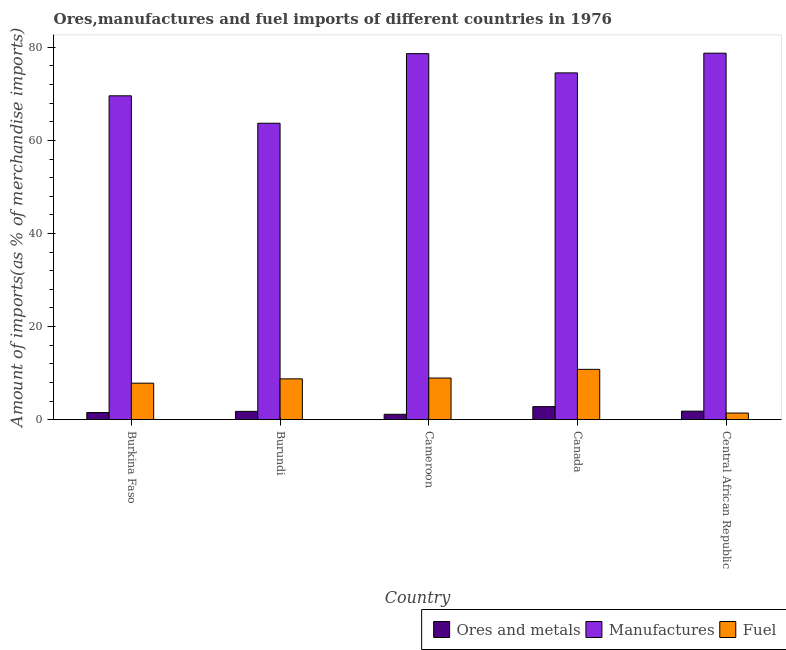Are the number of bars on each tick of the X-axis equal?
Make the answer very short. Yes. How many bars are there on the 4th tick from the left?
Your answer should be very brief. 3. How many bars are there on the 2nd tick from the right?
Make the answer very short. 3. What is the label of the 5th group of bars from the left?
Provide a short and direct response. Central African Republic. What is the percentage of manufactures imports in Cameroon?
Offer a very short reply. 78.63. Across all countries, what is the maximum percentage of manufactures imports?
Keep it short and to the point. 78.73. Across all countries, what is the minimum percentage of manufactures imports?
Make the answer very short. 63.69. In which country was the percentage of ores and metals imports maximum?
Offer a very short reply. Canada. In which country was the percentage of ores and metals imports minimum?
Give a very brief answer. Cameroon. What is the total percentage of manufactures imports in the graph?
Offer a very short reply. 365.13. What is the difference between the percentage of ores and metals imports in Canada and that in Central African Republic?
Provide a short and direct response. 0.97. What is the difference between the percentage of fuel imports in Burkina Faso and the percentage of ores and metals imports in Burundi?
Give a very brief answer. 6.06. What is the average percentage of ores and metals imports per country?
Offer a very short reply. 1.82. What is the difference between the percentage of ores and metals imports and percentage of manufactures imports in Cameroon?
Make the answer very short. -77.48. In how many countries, is the percentage of manufactures imports greater than 24 %?
Offer a very short reply. 5. What is the ratio of the percentage of fuel imports in Cameroon to that in Central African Republic?
Offer a terse response. 6.28. Is the difference between the percentage of ores and metals imports in Burkina Faso and Burundi greater than the difference between the percentage of manufactures imports in Burkina Faso and Burundi?
Give a very brief answer. No. What is the difference between the highest and the second highest percentage of fuel imports?
Your answer should be very brief. 1.87. What is the difference between the highest and the lowest percentage of fuel imports?
Your answer should be compact. 9.39. In how many countries, is the percentage of manufactures imports greater than the average percentage of manufactures imports taken over all countries?
Give a very brief answer. 3. What does the 2nd bar from the left in Burkina Faso represents?
Give a very brief answer. Manufactures. What does the 1st bar from the right in Central African Republic represents?
Your answer should be very brief. Fuel. Is it the case that in every country, the sum of the percentage of ores and metals imports and percentage of manufactures imports is greater than the percentage of fuel imports?
Give a very brief answer. Yes. How many bars are there?
Your answer should be compact. 15. Are all the bars in the graph horizontal?
Offer a very short reply. No. How many countries are there in the graph?
Provide a succinct answer. 5. Does the graph contain any zero values?
Provide a succinct answer. No. Where does the legend appear in the graph?
Offer a very short reply. Bottom right. How many legend labels are there?
Your answer should be compact. 3. How are the legend labels stacked?
Give a very brief answer. Horizontal. What is the title of the graph?
Keep it short and to the point. Ores,manufactures and fuel imports of different countries in 1976. What is the label or title of the X-axis?
Give a very brief answer. Country. What is the label or title of the Y-axis?
Offer a terse response. Amount of imports(as % of merchandise imports). What is the Amount of imports(as % of merchandise imports) in Ores and metals in Burkina Faso?
Give a very brief answer. 1.53. What is the Amount of imports(as % of merchandise imports) in Manufactures in Burkina Faso?
Ensure brevity in your answer.  69.58. What is the Amount of imports(as % of merchandise imports) of Fuel in Burkina Faso?
Offer a terse response. 7.85. What is the Amount of imports(as % of merchandise imports) of Ores and metals in Burundi?
Provide a succinct answer. 1.79. What is the Amount of imports(as % of merchandise imports) of Manufactures in Burundi?
Your response must be concise. 63.69. What is the Amount of imports(as % of merchandise imports) in Fuel in Burundi?
Your answer should be compact. 8.77. What is the Amount of imports(as % of merchandise imports) in Ores and metals in Cameroon?
Offer a terse response. 1.16. What is the Amount of imports(as % of merchandise imports) of Manufactures in Cameroon?
Offer a terse response. 78.63. What is the Amount of imports(as % of merchandise imports) in Fuel in Cameroon?
Give a very brief answer. 8.95. What is the Amount of imports(as % of merchandise imports) in Ores and metals in Canada?
Your answer should be very brief. 2.81. What is the Amount of imports(as % of merchandise imports) in Manufactures in Canada?
Offer a terse response. 74.5. What is the Amount of imports(as % of merchandise imports) in Fuel in Canada?
Offer a terse response. 10.82. What is the Amount of imports(as % of merchandise imports) of Ores and metals in Central African Republic?
Make the answer very short. 1.83. What is the Amount of imports(as % of merchandise imports) in Manufactures in Central African Republic?
Provide a succinct answer. 78.73. What is the Amount of imports(as % of merchandise imports) in Fuel in Central African Republic?
Ensure brevity in your answer.  1.43. Across all countries, what is the maximum Amount of imports(as % of merchandise imports) in Ores and metals?
Ensure brevity in your answer.  2.81. Across all countries, what is the maximum Amount of imports(as % of merchandise imports) of Manufactures?
Offer a very short reply. 78.73. Across all countries, what is the maximum Amount of imports(as % of merchandise imports) of Fuel?
Your response must be concise. 10.82. Across all countries, what is the minimum Amount of imports(as % of merchandise imports) in Ores and metals?
Offer a very short reply. 1.16. Across all countries, what is the minimum Amount of imports(as % of merchandise imports) of Manufactures?
Offer a terse response. 63.69. Across all countries, what is the minimum Amount of imports(as % of merchandise imports) in Fuel?
Provide a short and direct response. 1.43. What is the total Amount of imports(as % of merchandise imports) in Ores and metals in the graph?
Your response must be concise. 9.12. What is the total Amount of imports(as % of merchandise imports) in Manufactures in the graph?
Your answer should be very brief. 365.13. What is the total Amount of imports(as % of merchandise imports) of Fuel in the graph?
Ensure brevity in your answer.  37.81. What is the difference between the Amount of imports(as % of merchandise imports) of Ores and metals in Burkina Faso and that in Burundi?
Offer a terse response. -0.25. What is the difference between the Amount of imports(as % of merchandise imports) in Manufactures in Burkina Faso and that in Burundi?
Make the answer very short. 5.89. What is the difference between the Amount of imports(as % of merchandise imports) in Fuel in Burkina Faso and that in Burundi?
Provide a succinct answer. -0.93. What is the difference between the Amount of imports(as % of merchandise imports) of Ores and metals in Burkina Faso and that in Cameroon?
Keep it short and to the point. 0.38. What is the difference between the Amount of imports(as % of merchandise imports) of Manufactures in Burkina Faso and that in Cameroon?
Provide a succinct answer. -9.06. What is the difference between the Amount of imports(as % of merchandise imports) of Fuel in Burkina Faso and that in Cameroon?
Provide a succinct answer. -1.1. What is the difference between the Amount of imports(as % of merchandise imports) in Ores and metals in Burkina Faso and that in Canada?
Your response must be concise. -1.27. What is the difference between the Amount of imports(as % of merchandise imports) of Manufactures in Burkina Faso and that in Canada?
Keep it short and to the point. -4.93. What is the difference between the Amount of imports(as % of merchandise imports) in Fuel in Burkina Faso and that in Canada?
Make the answer very short. -2.97. What is the difference between the Amount of imports(as % of merchandise imports) in Ores and metals in Burkina Faso and that in Central African Republic?
Your response must be concise. -0.3. What is the difference between the Amount of imports(as % of merchandise imports) of Manufactures in Burkina Faso and that in Central African Republic?
Your response must be concise. -9.15. What is the difference between the Amount of imports(as % of merchandise imports) in Fuel in Burkina Faso and that in Central African Republic?
Your response must be concise. 6.42. What is the difference between the Amount of imports(as % of merchandise imports) of Ores and metals in Burundi and that in Cameroon?
Give a very brief answer. 0.63. What is the difference between the Amount of imports(as % of merchandise imports) of Manufactures in Burundi and that in Cameroon?
Your answer should be compact. -14.95. What is the difference between the Amount of imports(as % of merchandise imports) in Fuel in Burundi and that in Cameroon?
Your response must be concise. -0.18. What is the difference between the Amount of imports(as % of merchandise imports) of Ores and metals in Burundi and that in Canada?
Your response must be concise. -1.02. What is the difference between the Amount of imports(as % of merchandise imports) in Manufactures in Burundi and that in Canada?
Ensure brevity in your answer.  -10.82. What is the difference between the Amount of imports(as % of merchandise imports) in Fuel in Burundi and that in Canada?
Provide a succinct answer. -2.04. What is the difference between the Amount of imports(as % of merchandise imports) of Ores and metals in Burundi and that in Central African Republic?
Give a very brief answer. -0.05. What is the difference between the Amount of imports(as % of merchandise imports) of Manufactures in Burundi and that in Central African Republic?
Keep it short and to the point. -15.05. What is the difference between the Amount of imports(as % of merchandise imports) in Fuel in Burundi and that in Central African Republic?
Offer a terse response. 7.35. What is the difference between the Amount of imports(as % of merchandise imports) in Ores and metals in Cameroon and that in Canada?
Provide a short and direct response. -1.65. What is the difference between the Amount of imports(as % of merchandise imports) in Manufactures in Cameroon and that in Canada?
Offer a terse response. 4.13. What is the difference between the Amount of imports(as % of merchandise imports) in Fuel in Cameroon and that in Canada?
Your response must be concise. -1.87. What is the difference between the Amount of imports(as % of merchandise imports) in Ores and metals in Cameroon and that in Central African Republic?
Provide a succinct answer. -0.68. What is the difference between the Amount of imports(as % of merchandise imports) of Manufactures in Cameroon and that in Central African Republic?
Give a very brief answer. -0.1. What is the difference between the Amount of imports(as % of merchandise imports) of Fuel in Cameroon and that in Central African Republic?
Give a very brief answer. 7.52. What is the difference between the Amount of imports(as % of merchandise imports) of Ores and metals in Canada and that in Central African Republic?
Your answer should be compact. 0.97. What is the difference between the Amount of imports(as % of merchandise imports) of Manufactures in Canada and that in Central African Republic?
Make the answer very short. -4.23. What is the difference between the Amount of imports(as % of merchandise imports) in Fuel in Canada and that in Central African Republic?
Offer a very short reply. 9.39. What is the difference between the Amount of imports(as % of merchandise imports) in Ores and metals in Burkina Faso and the Amount of imports(as % of merchandise imports) in Manufactures in Burundi?
Provide a short and direct response. -62.15. What is the difference between the Amount of imports(as % of merchandise imports) of Ores and metals in Burkina Faso and the Amount of imports(as % of merchandise imports) of Fuel in Burundi?
Your answer should be compact. -7.24. What is the difference between the Amount of imports(as % of merchandise imports) in Manufactures in Burkina Faso and the Amount of imports(as % of merchandise imports) in Fuel in Burundi?
Offer a very short reply. 60.81. What is the difference between the Amount of imports(as % of merchandise imports) of Ores and metals in Burkina Faso and the Amount of imports(as % of merchandise imports) of Manufactures in Cameroon?
Provide a succinct answer. -77.1. What is the difference between the Amount of imports(as % of merchandise imports) in Ores and metals in Burkina Faso and the Amount of imports(as % of merchandise imports) in Fuel in Cameroon?
Make the answer very short. -7.41. What is the difference between the Amount of imports(as % of merchandise imports) in Manufactures in Burkina Faso and the Amount of imports(as % of merchandise imports) in Fuel in Cameroon?
Make the answer very short. 60.63. What is the difference between the Amount of imports(as % of merchandise imports) in Ores and metals in Burkina Faso and the Amount of imports(as % of merchandise imports) in Manufactures in Canada?
Make the answer very short. -72.97. What is the difference between the Amount of imports(as % of merchandise imports) of Ores and metals in Burkina Faso and the Amount of imports(as % of merchandise imports) of Fuel in Canada?
Offer a very short reply. -9.28. What is the difference between the Amount of imports(as % of merchandise imports) of Manufactures in Burkina Faso and the Amount of imports(as % of merchandise imports) of Fuel in Canada?
Keep it short and to the point. 58.76. What is the difference between the Amount of imports(as % of merchandise imports) of Ores and metals in Burkina Faso and the Amount of imports(as % of merchandise imports) of Manufactures in Central African Republic?
Offer a terse response. -77.2. What is the difference between the Amount of imports(as % of merchandise imports) in Ores and metals in Burkina Faso and the Amount of imports(as % of merchandise imports) in Fuel in Central African Republic?
Give a very brief answer. 0.11. What is the difference between the Amount of imports(as % of merchandise imports) of Manufactures in Burkina Faso and the Amount of imports(as % of merchandise imports) of Fuel in Central African Republic?
Your answer should be compact. 68.15. What is the difference between the Amount of imports(as % of merchandise imports) in Ores and metals in Burundi and the Amount of imports(as % of merchandise imports) in Manufactures in Cameroon?
Your answer should be compact. -76.85. What is the difference between the Amount of imports(as % of merchandise imports) of Ores and metals in Burundi and the Amount of imports(as % of merchandise imports) of Fuel in Cameroon?
Keep it short and to the point. -7.16. What is the difference between the Amount of imports(as % of merchandise imports) in Manufactures in Burundi and the Amount of imports(as % of merchandise imports) in Fuel in Cameroon?
Keep it short and to the point. 54.74. What is the difference between the Amount of imports(as % of merchandise imports) in Ores and metals in Burundi and the Amount of imports(as % of merchandise imports) in Manufactures in Canada?
Provide a short and direct response. -72.72. What is the difference between the Amount of imports(as % of merchandise imports) of Ores and metals in Burundi and the Amount of imports(as % of merchandise imports) of Fuel in Canada?
Offer a very short reply. -9.03. What is the difference between the Amount of imports(as % of merchandise imports) of Manufactures in Burundi and the Amount of imports(as % of merchandise imports) of Fuel in Canada?
Provide a short and direct response. 52.87. What is the difference between the Amount of imports(as % of merchandise imports) of Ores and metals in Burundi and the Amount of imports(as % of merchandise imports) of Manufactures in Central African Republic?
Offer a terse response. -76.95. What is the difference between the Amount of imports(as % of merchandise imports) of Ores and metals in Burundi and the Amount of imports(as % of merchandise imports) of Fuel in Central African Republic?
Provide a succinct answer. 0.36. What is the difference between the Amount of imports(as % of merchandise imports) in Manufactures in Burundi and the Amount of imports(as % of merchandise imports) in Fuel in Central African Republic?
Provide a succinct answer. 62.26. What is the difference between the Amount of imports(as % of merchandise imports) in Ores and metals in Cameroon and the Amount of imports(as % of merchandise imports) in Manufactures in Canada?
Make the answer very short. -73.35. What is the difference between the Amount of imports(as % of merchandise imports) of Ores and metals in Cameroon and the Amount of imports(as % of merchandise imports) of Fuel in Canada?
Provide a succinct answer. -9.66. What is the difference between the Amount of imports(as % of merchandise imports) in Manufactures in Cameroon and the Amount of imports(as % of merchandise imports) in Fuel in Canada?
Provide a short and direct response. 67.82. What is the difference between the Amount of imports(as % of merchandise imports) in Ores and metals in Cameroon and the Amount of imports(as % of merchandise imports) in Manufactures in Central African Republic?
Your response must be concise. -77.57. What is the difference between the Amount of imports(as % of merchandise imports) in Ores and metals in Cameroon and the Amount of imports(as % of merchandise imports) in Fuel in Central African Republic?
Give a very brief answer. -0.27. What is the difference between the Amount of imports(as % of merchandise imports) of Manufactures in Cameroon and the Amount of imports(as % of merchandise imports) of Fuel in Central African Republic?
Keep it short and to the point. 77.21. What is the difference between the Amount of imports(as % of merchandise imports) in Ores and metals in Canada and the Amount of imports(as % of merchandise imports) in Manufactures in Central African Republic?
Ensure brevity in your answer.  -75.92. What is the difference between the Amount of imports(as % of merchandise imports) of Ores and metals in Canada and the Amount of imports(as % of merchandise imports) of Fuel in Central African Republic?
Offer a terse response. 1.38. What is the difference between the Amount of imports(as % of merchandise imports) of Manufactures in Canada and the Amount of imports(as % of merchandise imports) of Fuel in Central African Republic?
Your answer should be compact. 73.08. What is the average Amount of imports(as % of merchandise imports) in Ores and metals per country?
Your answer should be compact. 1.82. What is the average Amount of imports(as % of merchandise imports) in Manufactures per country?
Give a very brief answer. 73.03. What is the average Amount of imports(as % of merchandise imports) in Fuel per country?
Your answer should be very brief. 7.56. What is the difference between the Amount of imports(as % of merchandise imports) of Ores and metals and Amount of imports(as % of merchandise imports) of Manufactures in Burkina Faso?
Your response must be concise. -68.04. What is the difference between the Amount of imports(as % of merchandise imports) in Ores and metals and Amount of imports(as % of merchandise imports) in Fuel in Burkina Faso?
Make the answer very short. -6.31. What is the difference between the Amount of imports(as % of merchandise imports) of Manufactures and Amount of imports(as % of merchandise imports) of Fuel in Burkina Faso?
Provide a succinct answer. 61.73. What is the difference between the Amount of imports(as % of merchandise imports) of Ores and metals and Amount of imports(as % of merchandise imports) of Manufactures in Burundi?
Keep it short and to the point. -61.9. What is the difference between the Amount of imports(as % of merchandise imports) in Ores and metals and Amount of imports(as % of merchandise imports) in Fuel in Burundi?
Your response must be concise. -6.99. What is the difference between the Amount of imports(as % of merchandise imports) of Manufactures and Amount of imports(as % of merchandise imports) of Fuel in Burundi?
Provide a succinct answer. 54.91. What is the difference between the Amount of imports(as % of merchandise imports) of Ores and metals and Amount of imports(as % of merchandise imports) of Manufactures in Cameroon?
Your answer should be compact. -77.48. What is the difference between the Amount of imports(as % of merchandise imports) in Ores and metals and Amount of imports(as % of merchandise imports) in Fuel in Cameroon?
Your answer should be compact. -7.79. What is the difference between the Amount of imports(as % of merchandise imports) of Manufactures and Amount of imports(as % of merchandise imports) of Fuel in Cameroon?
Your response must be concise. 69.69. What is the difference between the Amount of imports(as % of merchandise imports) in Ores and metals and Amount of imports(as % of merchandise imports) in Manufactures in Canada?
Provide a short and direct response. -71.7. What is the difference between the Amount of imports(as % of merchandise imports) in Ores and metals and Amount of imports(as % of merchandise imports) in Fuel in Canada?
Ensure brevity in your answer.  -8.01. What is the difference between the Amount of imports(as % of merchandise imports) of Manufactures and Amount of imports(as % of merchandise imports) of Fuel in Canada?
Give a very brief answer. 63.69. What is the difference between the Amount of imports(as % of merchandise imports) in Ores and metals and Amount of imports(as % of merchandise imports) in Manufactures in Central African Republic?
Offer a terse response. -76.9. What is the difference between the Amount of imports(as % of merchandise imports) of Ores and metals and Amount of imports(as % of merchandise imports) of Fuel in Central African Republic?
Ensure brevity in your answer.  0.41. What is the difference between the Amount of imports(as % of merchandise imports) in Manufactures and Amount of imports(as % of merchandise imports) in Fuel in Central African Republic?
Your answer should be compact. 77.31. What is the ratio of the Amount of imports(as % of merchandise imports) in Ores and metals in Burkina Faso to that in Burundi?
Provide a short and direct response. 0.86. What is the ratio of the Amount of imports(as % of merchandise imports) of Manufactures in Burkina Faso to that in Burundi?
Offer a very short reply. 1.09. What is the ratio of the Amount of imports(as % of merchandise imports) of Fuel in Burkina Faso to that in Burundi?
Keep it short and to the point. 0.89. What is the ratio of the Amount of imports(as % of merchandise imports) in Ores and metals in Burkina Faso to that in Cameroon?
Provide a succinct answer. 1.33. What is the ratio of the Amount of imports(as % of merchandise imports) of Manufactures in Burkina Faso to that in Cameroon?
Give a very brief answer. 0.88. What is the ratio of the Amount of imports(as % of merchandise imports) in Fuel in Burkina Faso to that in Cameroon?
Keep it short and to the point. 0.88. What is the ratio of the Amount of imports(as % of merchandise imports) of Ores and metals in Burkina Faso to that in Canada?
Ensure brevity in your answer.  0.55. What is the ratio of the Amount of imports(as % of merchandise imports) of Manufactures in Burkina Faso to that in Canada?
Ensure brevity in your answer.  0.93. What is the ratio of the Amount of imports(as % of merchandise imports) of Fuel in Burkina Faso to that in Canada?
Keep it short and to the point. 0.73. What is the ratio of the Amount of imports(as % of merchandise imports) in Ores and metals in Burkina Faso to that in Central African Republic?
Your answer should be very brief. 0.84. What is the ratio of the Amount of imports(as % of merchandise imports) of Manufactures in Burkina Faso to that in Central African Republic?
Your answer should be very brief. 0.88. What is the ratio of the Amount of imports(as % of merchandise imports) in Fuel in Burkina Faso to that in Central African Republic?
Make the answer very short. 5.5. What is the ratio of the Amount of imports(as % of merchandise imports) in Ores and metals in Burundi to that in Cameroon?
Make the answer very short. 1.54. What is the ratio of the Amount of imports(as % of merchandise imports) in Manufactures in Burundi to that in Cameroon?
Keep it short and to the point. 0.81. What is the ratio of the Amount of imports(as % of merchandise imports) in Fuel in Burundi to that in Cameroon?
Offer a terse response. 0.98. What is the ratio of the Amount of imports(as % of merchandise imports) in Ores and metals in Burundi to that in Canada?
Provide a short and direct response. 0.64. What is the ratio of the Amount of imports(as % of merchandise imports) in Manufactures in Burundi to that in Canada?
Provide a short and direct response. 0.85. What is the ratio of the Amount of imports(as % of merchandise imports) of Fuel in Burundi to that in Canada?
Keep it short and to the point. 0.81. What is the ratio of the Amount of imports(as % of merchandise imports) in Ores and metals in Burundi to that in Central African Republic?
Offer a very short reply. 0.97. What is the ratio of the Amount of imports(as % of merchandise imports) of Manufactures in Burundi to that in Central African Republic?
Keep it short and to the point. 0.81. What is the ratio of the Amount of imports(as % of merchandise imports) of Fuel in Burundi to that in Central African Republic?
Your answer should be very brief. 6.15. What is the ratio of the Amount of imports(as % of merchandise imports) in Ores and metals in Cameroon to that in Canada?
Ensure brevity in your answer.  0.41. What is the ratio of the Amount of imports(as % of merchandise imports) in Manufactures in Cameroon to that in Canada?
Ensure brevity in your answer.  1.06. What is the ratio of the Amount of imports(as % of merchandise imports) of Fuel in Cameroon to that in Canada?
Your answer should be compact. 0.83. What is the ratio of the Amount of imports(as % of merchandise imports) of Ores and metals in Cameroon to that in Central African Republic?
Give a very brief answer. 0.63. What is the ratio of the Amount of imports(as % of merchandise imports) in Fuel in Cameroon to that in Central African Republic?
Your answer should be very brief. 6.28. What is the ratio of the Amount of imports(as % of merchandise imports) in Ores and metals in Canada to that in Central African Republic?
Ensure brevity in your answer.  1.53. What is the ratio of the Amount of imports(as % of merchandise imports) of Manufactures in Canada to that in Central African Republic?
Make the answer very short. 0.95. What is the ratio of the Amount of imports(as % of merchandise imports) of Fuel in Canada to that in Central African Republic?
Keep it short and to the point. 7.59. What is the difference between the highest and the second highest Amount of imports(as % of merchandise imports) of Ores and metals?
Provide a short and direct response. 0.97. What is the difference between the highest and the second highest Amount of imports(as % of merchandise imports) in Manufactures?
Offer a terse response. 0.1. What is the difference between the highest and the second highest Amount of imports(as % of merchandise imports) in Fuel?
Your response must be concise. 1.87. What is the difference between the highest and the lowest Amount of imports(as % of merchandise imports) in Ores and metals?
Provide a short and direct response. 1.65. What is the difference between the highest and the lowest Amount of imports(as % of merchandise imports) in Manufactures?
Ensure brevity in your answer.  15.05. What is the difference between the highest and the lowest Amount of imports(as % of merchandise imports) of Fuel?
Provide a succinct answer. 9.39. 